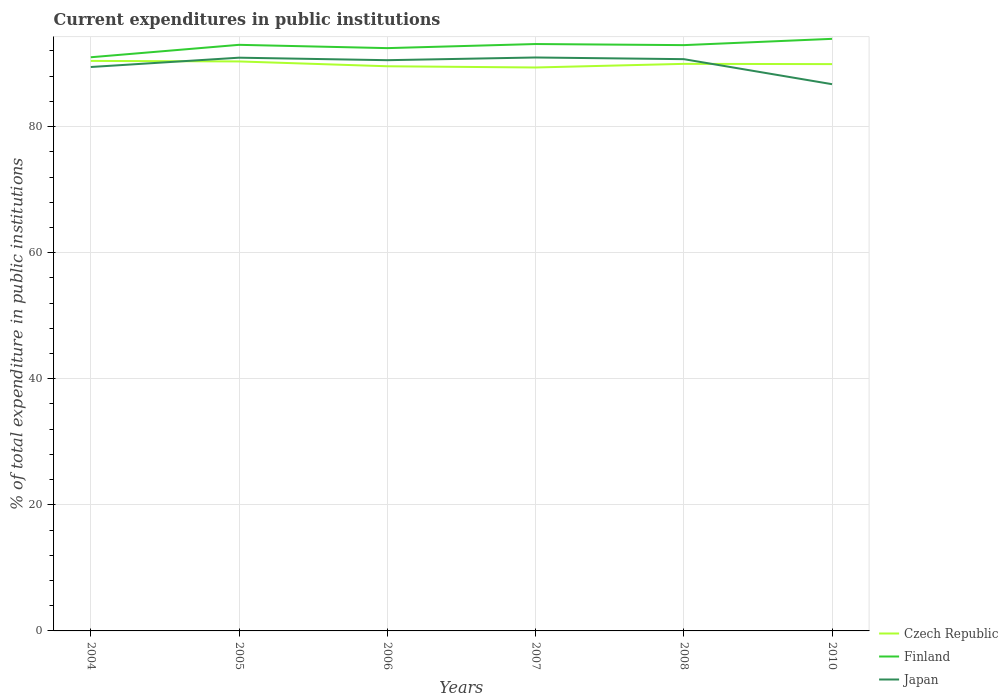How many different coloured lines are there?
Provide a short and direct response. 3. Does the line corresponding to Finland intersect with the line corresponding to Czech Republic?
Provide a short and direct response. No. Is the number of lines equal to the number of legend labels?
Offer a terse response. Yes. Across all years, what is the maximum current expenditures in public institutions in Czech Republic?
Provide a short and direct response. 89.38. In which year was the current expenditures in public institutions in Finland maximum?
Offer a terse response. 2004. What is the total current expenditures in public institutions in Finland in the graph?
Your response must be concise. 0.52. What is the difference between the highest and the second highest current expenditures in public institutions in Japan?
Your answer should be very brief. 4.24. What is the difference between the highest and the lowest current expenditures in public institutions in Finland?
Provide a succinct answer. 4. How many lines are there?
Offer a very short reply. 3. What is the difference between two consecutive major ticks on the Y-axis?
Offer a terse response. 20. Does the graph contain grids?
Offer a terse response. Yes. Where does the legend appear in the graph?
Your response must be concise. Bottom right. How many legend labels are there?
Offer a terse response. 3. What is the title of the graph?
Give a very brief answer. Current expenditures in public institutions. What is the label or title of the X-axis?
Keep it short and to the point. Years. What is the label or title of the Y-axis?
Keep it short and to the point. % of total expenditure in public institutions. What is the % of total expenditure in public institutions of Czech Republic in 2004?
Provide a short and direct response. 90.43. What is the % of total expenditure in public institutions of Finland in 2004?
Provide a succinct answer. 91. What is the % of total expenditure in public institutions of Japan in 2004?
Give a very brief answer. 89.46. What is the % of total expenditure in public institutions in Czech Republic in 2005?
Offer a terse response. 90.34. What is the % of total expenditure in public institutions of Finland in 2005?
Offer a terse response. 92.98. What is the % of total expenditure in public institutions of Japan in 2005?
Your answer should be compact. 90.94. What is the % of total expenditure in public institutions in Czech Republic in 2006?
Give a very brief answer. 89.57. What is the % of total expenditure in public institutions in Finland in 2006?
Your answer should be compact. 92.45. What is the % of total expenditure in public institutions in Japan in 2006?
Provide a succinct answer. 90.54. What is the % of total expenditure in public institutions of Czech Republic in 2007?
Offer a very short reply. 89.38. What is the % of total expenditure in public institutions of Finland in 2007?
Ensure brevity in your answer.  93.1. What is the % of total expenditure in public institutions in Japan in 2007?
Give a very brief answer. 90.97. What is the % of total expenditure in public institutions in Czech Republic in 2008?
Provide a short and direct response. 89.96. What is the % of total expenditure in public institutions of Finland in 2008?
Your response must be concise. 92.93. What is the % of total expenditure in public institutions of Japan in 2008?
Keep it short and to the point. 90.7. What is the % of total expenditure in public institutions in Czech Republic in 2010?
Your answer should be compact. 89.92. What is the % of total expenditure in public institutions in Finland in 2010?
Keep it short and to the point. 93.92. What is the % of total expenditure in public institutions of Japan in 2010?
Give a very brief answer. 86.73. Across all years, what is the maximum % of total expenditure in public institutions of Czech Republic?
Keep it short and to the point. 90.43. Across all years, what is the maximum % of total expenditure in public institutions of Finland?
Your answer should be very brief. 93.92. Across all years, what is the maximum % of total expenditure in public institutions of Japan?
Your answer should be very brief. 90.97. Across all years, what is the minimum % of total expenditure in public institutions of Czech Republic?
Your answer should be very brief. 89.38. Across all years, what is the minimum % of total expenditure in public institutions in Finland?
Provide a short and direct response. 91. Across all years, what is the minimum % of total expenditure in public institutions of Japan?
Provide a succinct answer. 86.73. What is the total % of total expenditure in public institutions of Czech Republic in the graph?
Ensure brevity in your answer.  539.59. What is the total % of total expenditure in public institutions of Finland in the graph?
Provide a succinct answer. 556.39. What is the total % of total expenditure in public institutions of Japan in the graph?
Offer a very short reply. 539.33. What is the difference between the % of total expenditure in public institutions of Czech Republic in 2004 and that in 2005?
Your answer should be very brief. 0.09. What is the difference between the % of total expenditure in public institutions of Finland in 2004 and that in 2005?
Ensure brevity in your answer.  -1.97. What is the difference between the % of total expenditure in public institutions in Japan in 2004 and that in 2005?
Offer a very short reply. -1.48. What is the difference between the % of total expenditure in public institutions of Czech Republic in 2004 and that in 2006?
Provide a short and direct response. 0.85. What is the difference between the % of total expenditure in public institutions in Finland in 2004 and that in 2006?
Offer a terse response. -1.45. What is the difference between the % of total expenditure in public institutions in Japan in 2004 and that in 2006?
Ensure brevity in your answer.  -1.08. What is the difference between the % of total expenditure in public institutions in Czech Republic in 2004 and that in 2007?
Offer a terse response. 1.04. What is the difference between the % of total expenditure in public institutions in Finland in 2004 and that in 2007?
Make the answer very short. -2.1. What is the difference between the % of total expenditure in public institutions of Japan in 2004 and that in 2007?
Your response must be concise. -1.51. What is the difference between the % of total expenditure in public institutions of Czech Republic in 2004 and that in 2008?
Give a very brief answer. 0.47. What is the difference between the % of total expenditure in public institutions in Finland in 2004 and that in 2008?
Give a very brief answer. -1.92. What is the difference between the % of total expenditure in public institutions of Japan in 2004 and that in 2008?
Your response must be concise. -1.24. What is the difference between the % of total expenditure in public institutions of Czech Republic in 2004 and that in 2010?
Offer a very short reply. 0.51. What is the difference between the % of total expenditure in public institutions of Finland in 2004 and that in 2010?
Your response must be concise. -2.92. What is the difference between the % of total expenditure in public institutions of Japan in 2004 and that in 2010?
Your answer should be very brief. 2.73. What is the difference between the % of total expenditure in public institutions in Czech Republic in 2005 and that in 2006?
Your answer should be very brief. 0.77. What is the difference between the % of total expenditure in public institutions in Finland in 2005 and that in 2006?
Your answer should be compact. 0.52. What is the difference between the % of total expenditure in public institutions of Japan in 2005 and that in 2006?
Ensure brevity in your answer.  0.4. What is the difference between the % of total expenditure in public institutions of Czech Republic in 2005 and that in 2007?
Your answer should be very brief. 0.96. What is the difference between the % of total expenditure in public institutions in Finland in 2005 and that in 2007?
Your response must be concise. -0.13. What is the difference between the % of total expenditure in public institutions of Japan in 2005 and that in 2007?
Give a very brief answer. -0.03. What is the difference between the % of total expenditure in public institutions of Czech Republic in 2005 and that in 2008?
Ensure brevity in your answer.  0.38. What is the difference between the % of total expenditure in public institutions in Finland in 2005 and that in 2008?
Ensure brevity in your answer.  0.05. What is the difference between the % of total expenditure in public institutions of Japan in 2005 and that in 2008?
Provide a succinct answer. 0.23. What is the difference between the % of total expenditure in public institutions of Czech Republic in 2005 and that in 2010?
Keep it short and to the point. 0.42. What is the difference between the % of total expenditure in public institutions of Finland in 2005 and that in 2010?
Your answer should be compact. -0.95. What is the difference between the % of total expenditure in public institutions of Japan in 2005 and that in 2010?
Keep it short and to the point. 4.2. What is the difference between the % of total expenditure in public institutions of Czech Republic in 2006 and that in 2007?
Offer a terse response. 0.19. What is the difference between the % of total expenditure in public institutions in Finland in 2006 and that in 2007?
Offer a very short reply. -0.65. What is the difference between the % of total expenditure in public institutions in Japan in 2006 and that in 2007?
Ensure brevity in your answer.  -0.43. What is the difference between the % of total expenditure in public institutions in Czech Republic in 2006 and that in 2008?
Your answer should be compact. -0.38. What is the difference between the % of total expenditure in public institutions of Finland in 2006 and that in 2008?
Your answer should be very brief. -0.47. What is the difference between the % of total expenditure in public institutions of Japan in 2006 and that in 2008?
Provide a succinct answer. -0.16. What is the difference between the % of total expenditure in public institutions in Czech Republic in 2006 and that in 2010?
Offer a very short reply. -0.34. What is the difference between the % of total expenditure in public institutions in Finland in 2006 and that in 2010?
Give a very brief answer. -1.47. What is the difference between the % of total expenditure in public institutions of Japan in 2006 and that in 2010?
Ensure brevity in your answer.  3.81. What is the difference between the % of total expenditure in public institutions in Czech Republic in 2007 and that in 2008?
Provide a succinct answer. -0.57. What is the difference between the % of total expenditure in public institutions in Finland in 2007 and that in 2008?
Provide a succinct answer. 0.17. What is the difference between the % of total expenditure in public institutions of Japan in 2007 and that in 2008?
Offer a terse response. 0.26. What is the difference between the % of total expenditure in public institutions of Czech Republic in 2007 and that in 2010?
Give a very brief answer. -0.54. What is the difference between the % of total expenditure in public institutions in Finland in 2007 and that in 2010?
Give a very brief answer. -0.82. What is the difference between the % of total expenditure in public institutions of Japan in 2007 and that in 2010?
Your answer should be compact. 4.24. What is the difference between the % of total expenditure in public institutions in Czech Republic in 2008 and that in 2010?
Offer a very short reply. 0.04. What is the difference between the % of total expenditure in public institutions of Finland in 2008 and that in 2010?
Provide a succinct answer. -1. What is the difference between the % of total expenditure in public institutions in Japan in 2008 and that in 2010?
Keep it short and to the point. 3.97. What is the difference between the % of total expenditure in public institutions in Czech Republic in 2004 and the % of total expenditure in public institutions in Finland in 2005?
Keep it short and to the point. -2.55. What is the difference between the % of total expenditure in public institutions of Czech Republic in 2004 and the % of total expenditure in public institutions of Japan in 2005?
Give a very brief answer. -0.51. What is the difference between the % of total expenditure in public institutions of Finland in 2004 and the % of total expenditure in public institutions of Japan in 2005?
Provide a succinct answer. 0.07. What is the difference between the % of total expenditure in public institutions in Czech Republic in 2004 and the % of total expenditure in public institutions in Finland in 2006?
Ensure brevity in your answer.  -2.03. What is the difference between the % of total expenditure in public institutions in Czech Republic in 2004 and the % of total expenditure in public institutions in Japan in 2006?
Keep it short and to the point. -0.11. What is the difference between the % of total expenditure in public institutions in Finland in 2004 and the % of total expenditure in public institutions in Japan in 2006?
Your answer should be very brief. 0.46. What is the difference between the % of total expenditure in public institutions in Czech Republic in 2004 and the % of total expenditure in public institutions in Finland in 2007?
Ensure brevity in your answer.  -2.68. What is the difference between the % of total expenditure in public institutions in Czech Republic in 2004 and the % of total expenditure in public institutions in Japan in 2007?
Offer a terse response. -0.54. What is the difference between the % of total expenditure in public institutions in Finland in 2004 and the % of total expenditure in public institutions in Japan in 2007?
Your answer should be very brief. 0.04. What is the difference between the % of total expenditure in public institutions in Czech Republic in 2004 and the % of total expenditure in public institutions in Finland in 2008?
Your answer should be compact. -2.5. What is the difference between the % of total expenditure in public institutions in Czech Republic in 2004 and the % of total expenditure in public institutions in Japan in 2008?
Offer a very short reply. -0.28. What is the difference between the % of total expenditure in public institutions in Finland in 2004 and the % of total expenditure in public institutions in Japan in 2008?
Provide a short and direct response. 0.3. What is the difference between the % of total expenditure in public institutions of Czech Republic in 2004 and the % of total expenditure in public institutions of Finland in 2010?
Keep it short and to the point. -3.5. What is the difference between the % of total expenditure in public institutions in Czech Republic in 2004 and the % of total expenditure in public institutions in Japan in 2010?
Provide a short and direct response. 3.7. What is the difference between the % of total expenditure in public institutions of Finland in 2004 and the % of total expenditure in public institutions of Japan in 2010?
Ensure brevity in your answer.  4.27. What is the difference between the % of total expenditure in public institutions of Czech Republic in 2005 and the % of total expenditure in public institutions of Finland in 2006?
Give a very brief answer. -2.11. What is the difference between the % of total expenditure in public institutions in Czech Republic in 2005 and the % of total expenditure in public institutions in Japan in 2006?
Provide a succinct answer. -0.2. What is the difference between the % of total expenditure in public institutions of Finland in 2005 and the % of total expenditure in public institutions of Japan in 2006?
Keep it short and to the point. 2.44. What is the difference between the % of total expenditure in public institutions in Czech Republic in 2005 and the % of total expenditure in public institutions in Finland in 2007?
Your response must be concise. -2.76. What is the difference between the % of total expenditure in public institutions of Czech Republic in 2005 and the % of total expenditure in public institutions of Japan in 2007?
Your response must be concise. -0.63. What is the difference between the % of total expenditure in public institutions in Finland in 2005 and the % of total expenditure in public institutions in Japan in 2007?
Provide a succinct answer. 2.01. What is the difference between the % of total expenditure in public institutions of Czech Republic in 2005 and the % of total expenditure in public institutions of Finland in 2008?
Your response must be concise. -2.59. What is the difference between the % of total expenditure in public institutions of Czech Republic in 2005 and the % of total expenditure in public institutions of Japan in 2008?
Provide a short and direct response. -0.36. What is the difference between the % of total expenditure in public institutions in Finland in 2005 and the % of total expenditure in public institutions in Japan in 2008?
Offer a very short reply. 2.27. What is the difference between the % of total expenditure in public institutions in Czech Republic in 2005 and the % of total expenditure in public institutions in Finland in 2010?
Provide a succinct answer. -3.58. What is the difference between the % of total expenditure in public institutions of Czech Republic in 2005 and the % of total expenditure in public institutions of Japan in 2010?
Your answer should be compact. 3.61. What is the difference between the % of total expenditure in public institutions of Finland in 2005 and the % of total expenditure in public institutions of Japan in 2010?
Your answer should be compact. 6.24. What is the difference between the % of total expenditure in public institutions of Czech Republic in 2006 and the % of total expenditure in public institutions of Finland in 2007?
Your response must be concise. -3.53. What is the difference between the % of total expenditure in public institutions of Czech Republic in 2006 and the % of total expenditure in public institutions of Japan in 2007?
Your answer should be very brief. -1.39. What is the difference between the % of total expenditure in public institutions of Finland in 2006 and the % of total expenditure in public institutions of Japan in 2007?
Make the answer very short. 1.49. What is the difference between the % of total expenditure in public institutions of Czech Republic in 2006 and the % of total expenditure in public institutions of Finland in 2008?
Make the answer very short. -3.35. What is the difference between the % of total expenditure in public institutions in Czech Republic in 2006 and the % of total expenditure in public institutions in Japan in 2008?
Ensure brevity in your answer.  -1.13. What is the difference between the % of total expenditure in public institutions of Finland in 2006 and the % of total expenditure in public institutions of Japan in 2008?
Ensure brevity in your answer.  1.75. What is the difference between the % of total expenditure in public institutions of Czech Republic in 2006 and the % of total expenditure in public institutions of Finland in 2010?
Your answer should be very brief. -4.35. What is the difference between the % of total expenditure in public institutions in Czech Republic in 2006 and the % of total expenditure in public institutions in Japan in 2010?
Give a very brief answer. 2.84. What is the difference between the % of total expenditure in public institutions in Finland in 2006 and the % of total expenditure in public institutions in Japan in 2010?
Keep it short and to the point. 5.72. What is the difference between the % of total expenditure in public institutions in Czech Republic in 2007 and the % of total expenditure in public institutions in Finland in 2008?
Give a very brief answer. -3.55. What is the difference between the % of total expenditure in public institutions of Czech Republic in 2007 and the % of total expenditure in public institutions of Japan in 2008?
Your response must be concise. -1.32. What is the difference between the % of total expenditure in public institutions of Finland in 2007 and the % of total expenditure in public institutions of Japan in 2008?
Offer a terse response. 2.4. What is the difference between the % of total expenditure in public institutions of Czech Republic in 2007 and the % of total expenditure in public institutions of Finland in 2010?
Give a very brief answer. -4.54. What is the difference between the % of total expenditure in public institutions in Czech Republic in 2007 and the % of total expenditure in public institutions in Japan in 2010?
Offer a terse response. 2.65. What is the difference between the % of total expenditure in public institutions of Finland in 2007 and the % of total expenditure in public institutions of Japan in 2010?
Provide a succinct answer. 6.37. What is the difference between the % of total expenditure in public institutions of Czech Republic in 2008 and the % of total expenditure in public institutions of Finland in 2010?
Ensure brevity in your answer.  -3.97. What is the difference between the % of total expenditure in public institutions in Czech Republic in 2008 and the % of total expenditure in public institutions in Japan in 2010?
Make the answer very short. 3.22. What is the difference between the % of total expenditure in public institutions of Finland in 2008 and the % of total expenditure in public institutions of Japan in 2010?
Make the answer very short. 6.2. What is the average % of total expenditure in public institutions in Czech Republic per year?
Provide a short and direct response. 89.93. What is the average % of total expenditure in public institutions of Finland per year?
Make the answer very short. 92.73. What is the average % of total expenditure in public institutions of Japan per year?
Provide a short and direct response. 89.89. In the year 2004, what is the difference between the % of total expenditure in public institutions of Czech Republic and % of total expenditure in public institutions of Finland?
Provide a succinct answer. -0.58. In the year 2004, what is the difference between the % of total expenditure in public institutions of Czech Republic and % of total expenditure in public institutions of Japan?
Your response must be concise. 0.97. In the year 2004, what is the difference between the % of total expenditure in public institutions in Finland and % of total expenditure in public institutions in Japan?
Provide a succinct answer. 1.55. In the year 2005, what is the difference between the % of total expenditure in public institutions of Czech Republic and % of total expenditure in public institutions of Finland?
Provide a succinct answer. -2.64. In the year 2005, what is the difference between the % of total expenditure in public institutions in Czech Republic and % of total expenditure in public institutions in Japan?
Give a very brief answer. -0.59. In the year 2005, what is the difference between the % of total expenditure in public institutions in Finland and % of total expenditure in public institutions in Japan?
Make the answer very short. 2.04. In the year 2006, what is the difference between the % of total expenditure in public institutions of Czech Republic and % of total expenditure in public institutions of Finland?
Make the answer very short. -2.88. In the year 2006, what is the difference between the % of total expenditure in public institutions in Czech Republic and % of total expenditure in public institutions in Japan?
Offer a very short reply. -0.96. In the year 2006, what is the difference between the % of total expenditure in public institutions in Finland and % of total expenditure in public institutions in Japan?
Keep it short and to the point. 1.91. In the year 2007, what is the difference between the % of total expenditure in public institutions of Czech Republic and % of total expenditure in public institutions of Finland?
Give a very brief answer. -3.72. In the year 2007, what is the difference between the % of total expenditure in public institutions in Czech Republic and % of total expenditure in public institutions in Japan?
Your answer should be compact. -1.59. In the year 2007, what is the difference between the % of total expenditure in public institutions of Finland and % of total expenditure in public institutions of Japan?
Your answer should be compact. 2.13. In the year 2008, what is the difference between the % of total expenditure in public institutions of Czech Republic and % of total expenditure in public institutions of Finland?
Provide a succinct answer. -2.97. In the year 2008, what is the difference between the % of total expenditure in public institutions in Czech Republic and % of total expenditure in public institutions in Japan?
Keep it short and to the point. -0.75. In the year 2008, what is the difference between the % of total expenditure in public institutions in Finland and % of total expenditure in public institutions in Japan?
Your response must be concise. 2.23. In the year 2010, what is the difference between the % of total expenditure in public institutions in Czech Republic and % of total expenditure in public institutions in Finland?
Give a very brief answer. -4.01. In the year 2010, what is the difference between the % of total expenditure in public institutions in Czech Republic and % of total expenditure in public institutions in Japan?
Make the answer very short. 3.19. In the year 2010, what is the difference between the % of total expenditure in public institutions of Finland and % of total expenditure in public institutions of Japan?
Provide a succinct answer. 7.19. What is the ratio of the % of total expenditure in public institutions of Finland in 2004 to that in 2005?
Provide a short and direct response. 0.98. What is the ratio of the % of total expenditure in public institutions in Japan in 2004 to that in 2005?
Your answer should be compact. 0.98. What is the ratio of the % of total expenditure in public institutions in Czech Republic in 2004 to that in 2006?
Your answer should be very brief. 1.01. What is the ratio of the % of total expenditure in public institutions of Finland in 2004 to that in 2006?
Provide a short and direct response. 0.98. What is the ratio of the % of total expenditure in public institutions of Japan in 2004 to that in 2006?
Your answer should be compact. 0.99. What is the ratio of the % of total expenditure in public institutions of Czech Republic in 2004 to that in 2007?
Your answer should be compact. 1.01. What is the ratio of the % of total expenditure in public institutions in Finland in 2004 to that in 2007?
Offer a terse response. 0.98. What is the ratio of the % of total expenditure in public institutions in Japan in 2004 to that in 2007?
Your response must be concise. 0.98. What is the ratio of the % of total expenditure in public institutions in Finland in 2004 to that in 2008?
Ensure brevity in your answer.  0.98. What is the ratio of the % of total expenditure in public institutions in Japan in 2004 to that in 2008?
Offer a very short reply. 0.99. What is the ratio of the % of total expenditure in public institutions of Czech Republic in 2004 to that in 2010?
Provide a succinct answer. 1.01. What is the ratio of the % of total expenditure in public institutions of Finland in 2004 to that in 2010?
Ensure brevity in your answer.  0.97. What is the ratio of the % of total expenditure in public institutions of Japan in 2004 to that in 2010?
Offer a very short reply. 1.03. What is the ratio of the % of total expenditure in public institutions of Czech Republic in 2005 to that in 2006?
Your response must be concise. 1.01. What is the ratio of the % of total expenditure in public institutions of Finland in 2005 to that in 2006?
Offer a very short reply. 1.01. What is the ratio of the % of total expenditure in public institutions in Czech Republic in 2005 to that in 2007?
Provide a succinct answer. 1.01. What is the ratio of the % of total expenditure in public institutions in Czech Republic in 2005 to that in 2008?
Your answer should be very brief. 1. What is the ratio of the % of total expenditure in public institutions of Finland in 2005 to that in 2008?
Provide a succinct answer. 1. What is the ratio of the % of total expenditure in public institutions of Japan in 2005 to that in 2008?
Offer a terse response. 1. What is the ratio of the % of total expenditure in public institutions of Czech Republic in 2005 to that in 2010?
Your answer should be compact. 1. What is the ratio of the % of total expenditure in public institutions of Japan in 2005 to that in 2010?
Give a very brief answer. 1.05. What is the ratio of the % of total expenditure in public institutions in Czech Republic in 2006 to that in 2007?
Ensure brevity in your answer.  1. What is the ratio of the % of total expenditure in public institutions of Finland in 2006 to that in 2007?
Your answer should be compact. 0.99. What is the ratio of the % of total expenditure in public institutions in Finland in 2006 to that in 2008?
Provide a succinct answer. 0.99. What is the ratio of the % of total expenditure in public institutions in Japan in 2006 to that in 2008?
Your answer should be compact. 1. What is the ratio of the % of total expenditure in public institutions of Finland in 2006 to that in 2010?
Ensure brevity in your answer.  0.98. What is the ratio of the % of total expenditure in public institutions of Japan in 2006 to that in 2010?
Your response must be concise. 1.04. What is the ratio of the % of total expenditure in public institutions in Czech Republic in 2007 to that in 2008?
Make the answer very short. 0.99. What is the ratio of the % of total expenditure in public institutions in Finland in 2007 to that in 2008?
Make the answer very short. 1. What is the ratio of the % of total expenditure in public institutions in Czech Republic in 2007 to that in 2010?
Provide a short and direct response. 0.99. What is the ratio of the % of total expenditure in public institutions in Japan in 2007 to that in 2010?
Offer a terse response. 1.05. What is the ratio of the % of total expenditure in public institutions in Japan in 2008 to that in 2010?
Provide a succinct answer. 1.05. What is the difference between the highest and the second highest % of total expenditure in public institutions of Czech Republic?
Ensure brevity in your answer.  0.09. What is the difference between the highest and the second highest % of total expenditure in public institutions of Finland?
Your answer should be compact. 0.82. What is the difference between the highest and the second highest % of total expenditure in public institutions of Japan?
Ensure brevity in your answer.  0.03. What is the difference between the highest and the lowest % of total expenditure in public institutions of Czech Republic?
Your response must be concise. 1.04. What is the difference between the highest and the lowest % of total expenditure in public institutions of Finland?
Provide a succinct answer. 2.92. What is the difference between the highest and the lowest % of total expenditure in public institutions in Japan?
Keep it short and to the point. 4.24. 